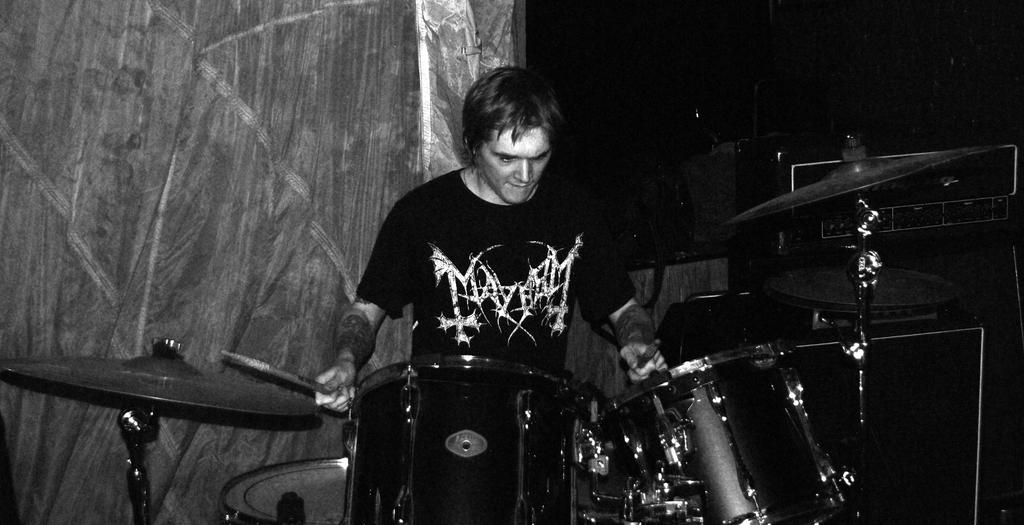Who is the main subject in the image? There is a man in the center of the image. What is the man holding in his hands? The man is holding sticks in his hands. What else can be seen in the image besides the man? There are musical instruments in the image. What can be seen in the background of the image? There is a curtain in the background of the image. What type of skate is the man wearing in the image? There is no skate present in the image; the man is holding sticks and there are musical instruments. How does the man grip the sticks in his hands? The image does not provide enough detail to determine how the man is gripping the sticks in his hands. 